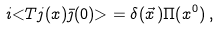Convert formula to latex. <formula><loc_0><loc_0><loc_500><loc_500>i { < } T j ( x ) \bar { \jmath } ( 0 ) { > } = \delta ( \vec { x } \, ) \Pi ( x ^ { 0 } ) \, ,</formula> 